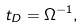<formula> <loc_0><loc_0><loc_500><loc_500>t _ { D } = \Omega ^ { - 1 } ,</formula> 